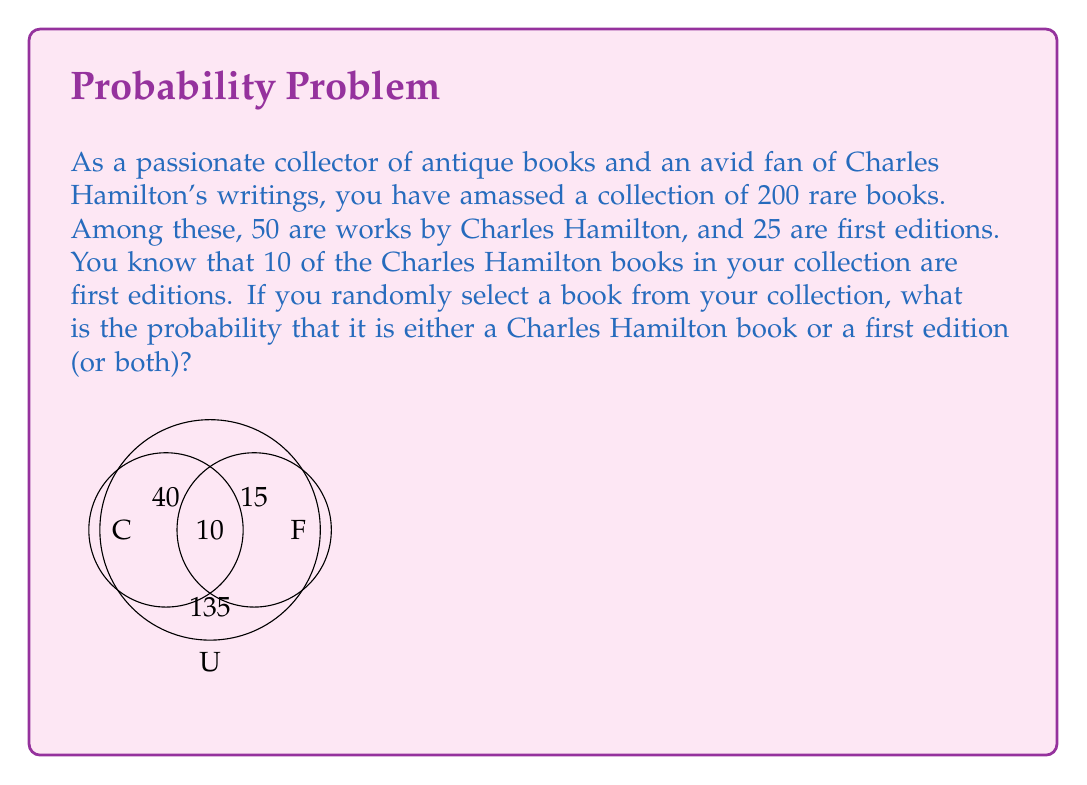Can you answer this question? Let's approach this step-by-step using set theory:

1) Define our sets:
   U = Universal set (all books in the collection)
   C = Set of Charles Hamilton books
   F = Set of first editions

2) Given information:
   $|U| = 200$ (total number of books)
   $|C| = 50$ (number of Charles Hamilton books)
   $|F| = 25$ (number of first editions)
   $|C \cap F| = 10$ (number of Charles Hamilton books that are also first editions)

3) We need to find $P(C \cup F)$, the probability of selecting a book that is either by Charles Hamilton or a first edition (or both).

4) Using the addition principle of probability:
   $P(C \cup F) = P(C) + P(F) - P(C \cap F)$

5) Calculate each probability:
   $P(C) = \frac{|C|}{|U|} = \frac{50}{200} = \frac{1}{4}$
   $P(F) = \frac{|F|}{|U|} = \frac{25}{200} = \frac{1}{8}$
   $P(C \cap F) = \frac{|C \cap F|}{|U|} = \frac{10}{200} = \frac{1}{20}$

6) Substitute into the formula:
   $P(C \cup F) = \frac{1}{4} + \frac{1}{8} - \frac{1}{20}$

7) Find a common denominator (40) and simplify:
   $P(C \cup F) = \frac{10}{40} + \frac{5}{40} - \frac{2}{40} = \frac{13}{40}$

Therefore, the probability of randomly selecting a book that is either by Charles Hamilton or a first edition (or both) is $\frac{13}{40}$.
Answer: $\frac{13}{40}$ 